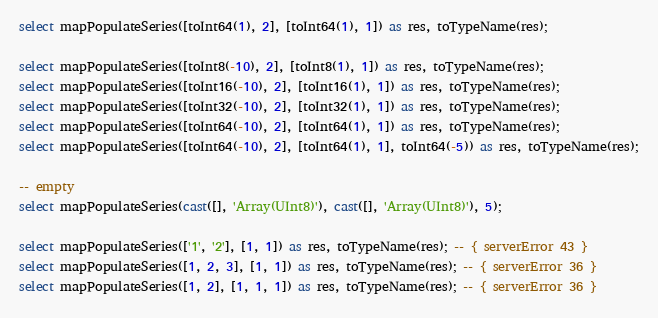<code> <loc_0><loc_0><loc_500><loc_500><_SQL_>select mapPopulateSeries([toInt64(1), 2], [toInt64(1), 1]) as res, toTypeName(res);

select mapPopulateSeries([toInt8(-10), 2], [toInt8(1), 1]) as res, toTypeName(res);
select mapPopulateSeries([toInt16(-10), 2], [toInt16(1), 1]) as res, toTypeName(res);
select mapPopulateSeries([toInt32(-10), 2], [toInt32(1), 1]) as res, toTypeName(res);
select mapPopulateSeries([toInt64(-10), 2], [toInt64(1), 1]) as res, toTypeName(res);
select mapPopulateSeries([toInt64(-10), 2], [toInt64(1), 1], toInt64(-5)) as res, toTypeName(res);

-- empty
select mapPopulateSeries(cast([], 'Array(UInt8)'), cast([], 'Array(UInt8)'), 5);

select mapPopulateSeries(['1', '2'], [1, 1]) as res, toTypeName(res); -- { serverError 43 }
select mapPopulateSeries([1, 2, 3], [1, 1]) as res, toTypeName(res); -- { serverError 36 }
select mapPopulateSeries([1, 2], [1, 1, 1]) as res, toTypeName(res); -- { serverError 36 }
</code> 